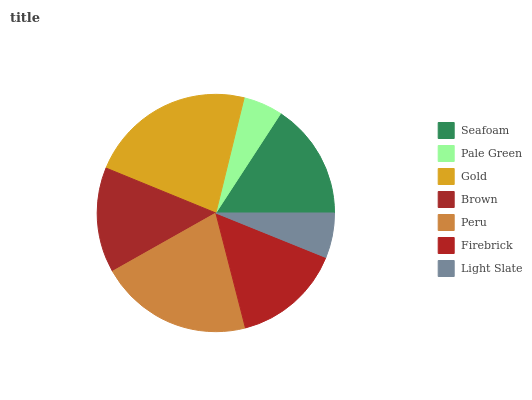Is Pale Green the minimum?
Answer yes or no. Yes. Is Gold the maximum?
Answer yes or no. Yes. Is Gold the minimum?
Answer yes or no. No. Is Pale Green the maximum?
Answer yes or no. No. Is Gold greater than Pale Green?
Answer yes or no. Yes. Is Pale Green less than Gold?
Answer yes or no. Yes. Is Pale Green greater than Gold?
Answer yes or no. No. Is Gold less than Pale Green?
Answer yes or no. No. Is Firebrick the high median?
Answer yes or no. Yes. Is Firebrick the low median?
Answer yes or no. Yes. Is Gold the high median?
Answer yes or no. No. Is Gold the low median?
Answer yes or no. No. 